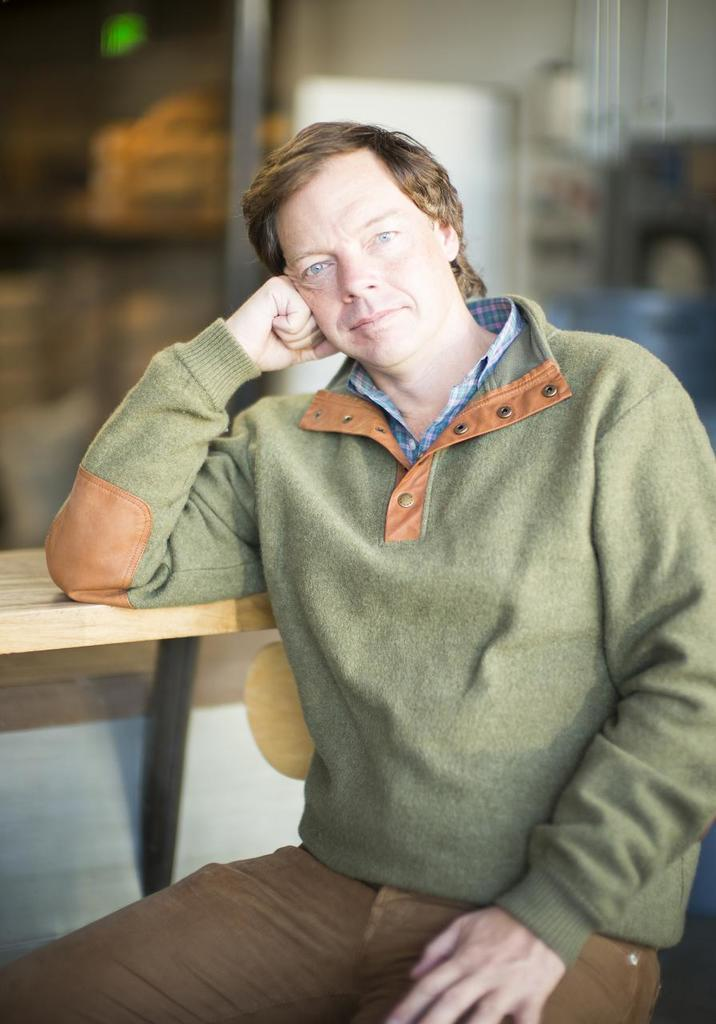What can be seen in the image? There is a person in the image. What is located on the left side of the image? There is a wooden object on the left side of the image. Can you describe the background of the image? The background of the image is blurred. Is there a crate being carried by the person's brother in the image? There is no crate or brother present in the image. Can you see a snail crawling on the wooden object in the image? There is no snail visible on the wooden object in the image. 